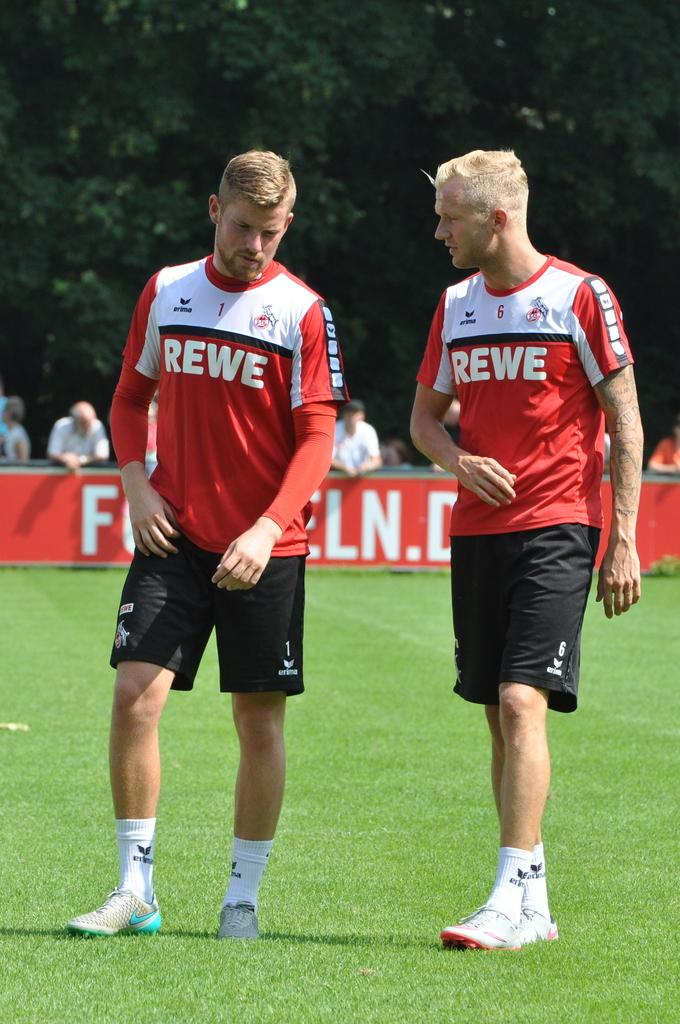<image>
Summarize the visual content of the image. Two players for REWE walk and talk on the field together. 